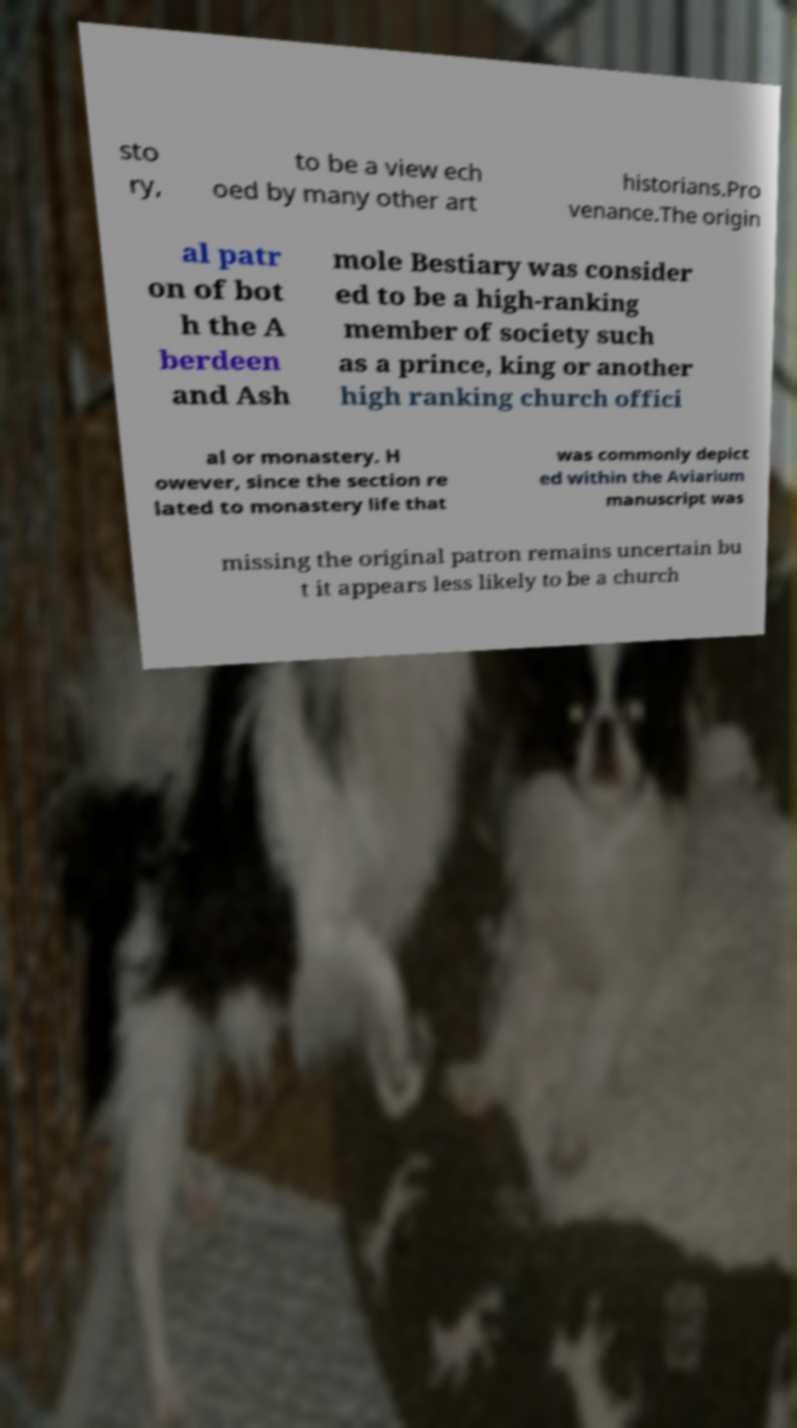Could you assist in decoding the text presented in this image and type it out clearly? sto ry, to be a view ech oed by many other art historians.Pro venance.The origin al patr on of bot h the A berdeen and Ash mole Bestiary was consider ed to be a high-ranking member of society such as a prince, king or another high ranking church offici al or monastery. H owever, since the section re lated to monastery life that was commonly depict ed within the Aviarium manuscript was missing the original patron remains uncertain bu t it appears less likely to be a church 